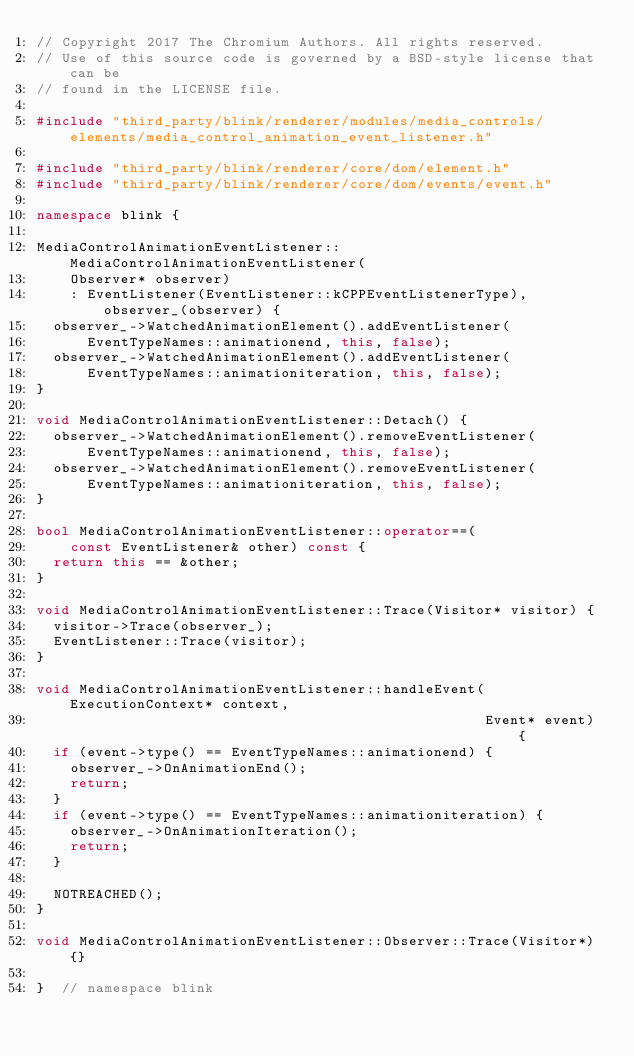<code> <loc_0><loc_0><loc_500><loc_500><_C++_>// Copyright 2017 The Chromium Authors. All rights reserved.
// Use of this source code is governed by a BSD-style license that can be
// found in the LICENSE file.

#include "third_party/blink/renderer/modules/media_controls/elements/media_control_animation_event_listener.h"

#include "third_party/blink/renderer/core/dom/element.h"
#include "third_party/blink/renderer/core/dom/events/event.h"

namespace blink {

MediaControlAnimationEventListener::MediaControlAnimationEventListener(
    Observer* observer)
    : EventListener(EventListener::kCPPEventListenerType), observer_(observer) {
  observer_->WatchedAnimationElement().addEventListener(
      EventTypeNames::animationend, this, false);
  observer_->WatchedAnimationElement().addEventListener(
      EventTypeNames::animationiteration, this, false);
}

void MediaControlAnimationEventListener::Detach() {
  observer_->WatchedAnimationElement().removeEventListener(
      EventTypeNames::animationend, this, false);
  observer_->WatchedAnimationElement().removeEventListener(
      EventTypeNames::animationiteration, this, false);
}

bool MediaControlAnimationEventListener::operator==(
    const EventListener& other) const {
  return this == &other;
}

void MediaControlAnimationEventListener::Trace(Visitor* visitor) {
  visitor->Trace(observer_);
  EventListener::Trace(visitor);
}

void MediaControlAnimationEventListener::handleEvent(ExecutionContext* context,
                                                     Event* event) {
  if (event->type() == EventTypeNames::animationend) {
    observer_->OnAnimationEnd();
    return;
  }
  if (event->type() == EventTypeNames::animationiteration) {
    observer_->OnAnimationIteration();
    return;
  }

  NOTREACHED();
}

void MediaControlAnimationEventListener::Observer::Trace(Visitor*) {}

}  // namespace blink
</code> 